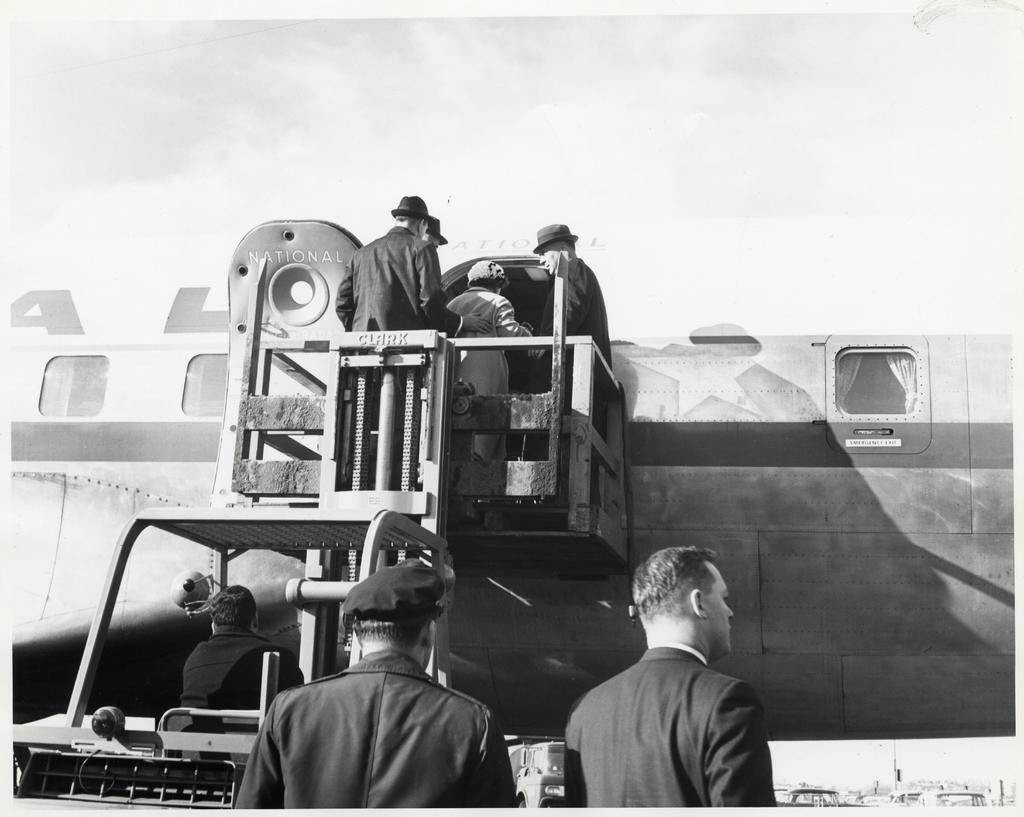What is the color scheme of the image? The image is black and white. How many people are in the image? There are two men in the image. Can you describe the vehicle in the image? There is a person in a vehicle. How many people are visible in the background? There are three people visible in the background. What can be seen in the background besides the people? There is an aircraft in the background. What is the weather like in the image? The sky is cloudy in the image. What type of voice can be heard coming from the aircraft in the image? There is no indication of any sound, including voices, in the image. Is there a cook visible in the image? There is no cook present in the image. What type of insect can be seen on the vehicle in the image? There are no insects visible on the vehicle or anywhere else in the image. 